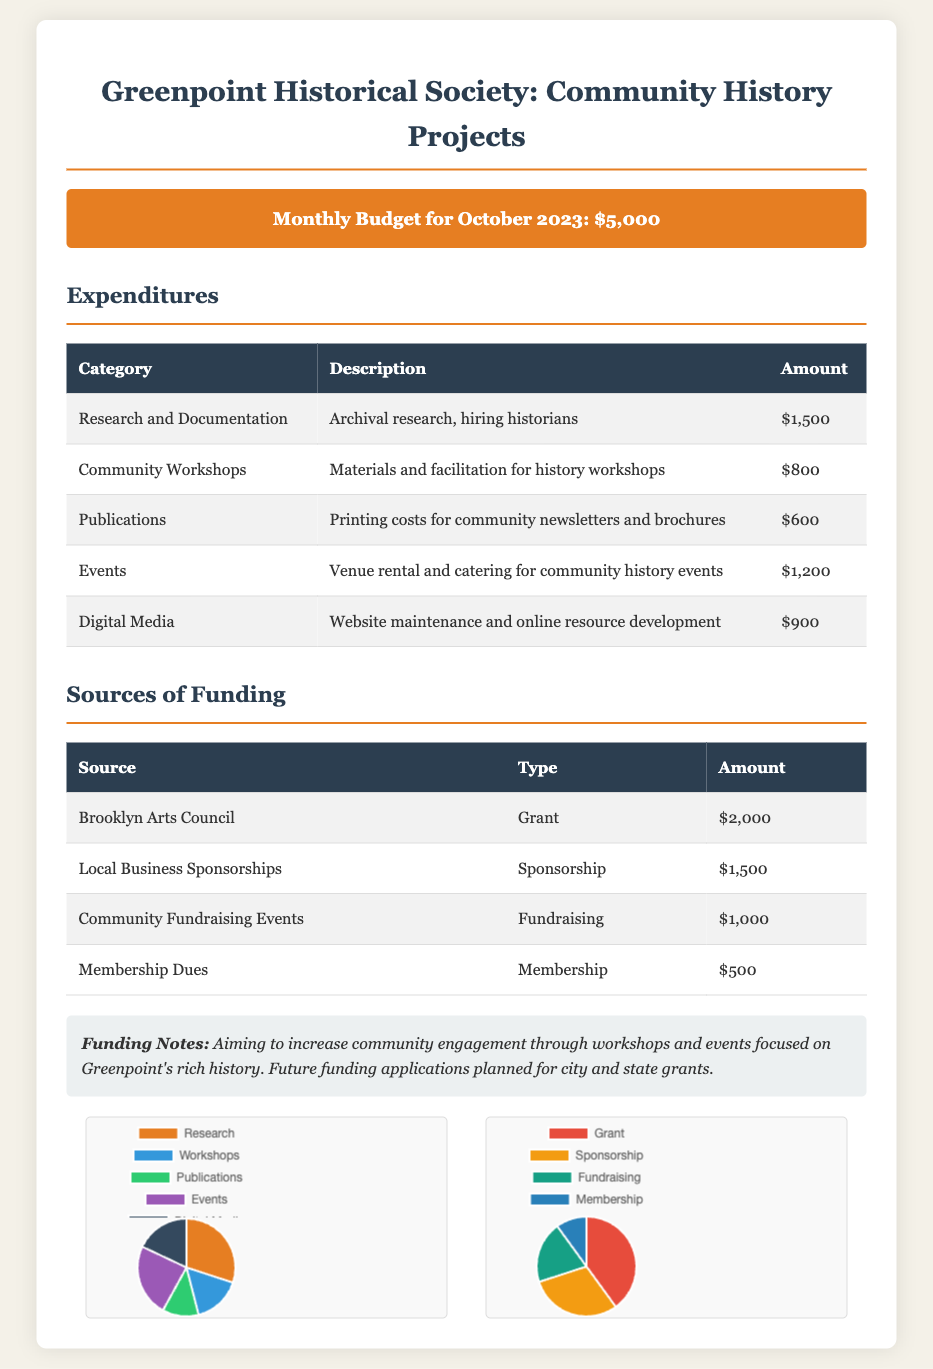What is the total monthly budget for October 2023? The total budget is stated in the budget overview section of the document.
Answer: $5,000 How much is allocated for research and documentation? The specific expenditure for research and documentation is detailed in the expenditures table.
Answer: $1,500 What is the amount received from local business sponsorships? The income from local business sponsorships is found in the sources of funding table.
Answer: $1,500 Which category has the highest expenditure? By examining the expenditures table, the category with the highest amount can be identified.
Answer: Events What percentage of the budget is spent on digital media? To find this, divide the digital media expenditure by the total budget and multiply by 100.
Answer: 18% What type of funding accounts for the lowest amount? This information is readily available in the funding sources table, listing types and amounts.
Answer: Membership Who is providing the largest grant? Identification of the largest grant source can be made through the sources of funding section.
Answer: Brooklyn Arts Council What is the purpose of the funding notes section? The funding notes provide context and intentions behind the financial activities mentioned.
Answer: Increase community engagement How much is allocated for community workshops? The amount for community workshops can be directly found in the expenditures breakdown.
Answer: $800 